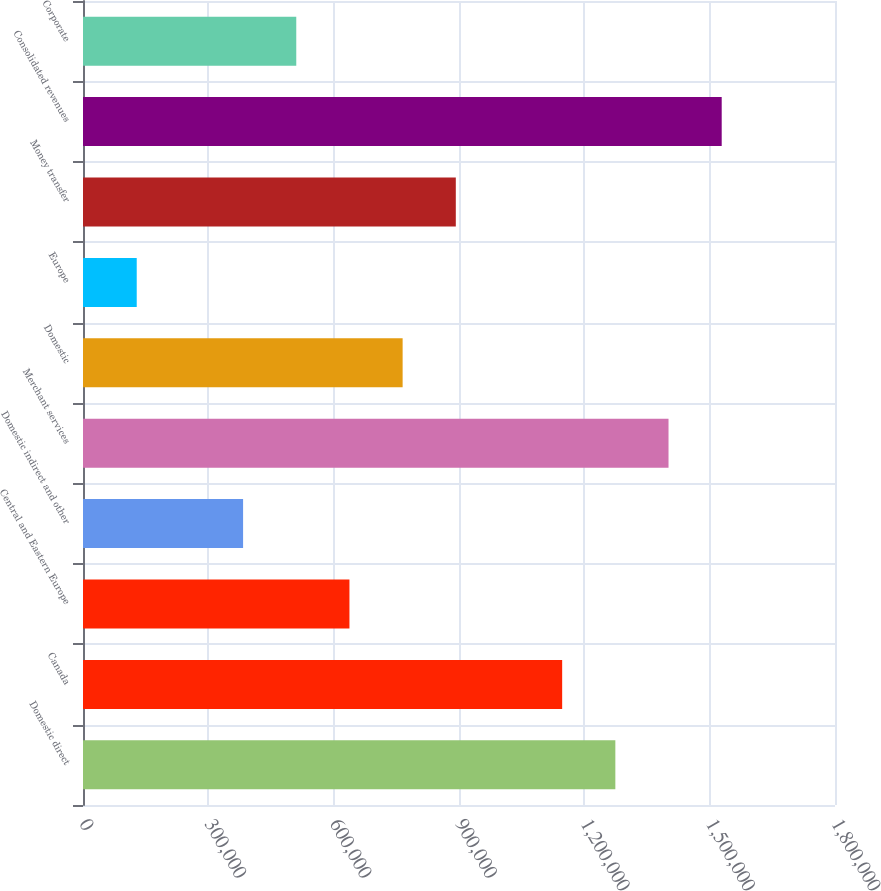Convert chart. <chart><loc_0><loc_0><loc_500><loc_500><bar_chart><fcel>Domestic direct<fcel>Canada<fcel>Central and Eastern Europe<fcel>Domestic indirect and other<fcel>Merchant services<fcel>Domestic<fcel>Europe<fcel>Money transfer<fcel>Consolidated revenues<fcel>Corporate<nl><fcel>1.27423e+06<fcel>1.14694e+06<fcel>637773<fcel>383191<fcel>1.40152e+06<fcel>765064<fcel>128608<fcel>892355<fcel>1.52881e+06<fcel>510482<nl></chart> 